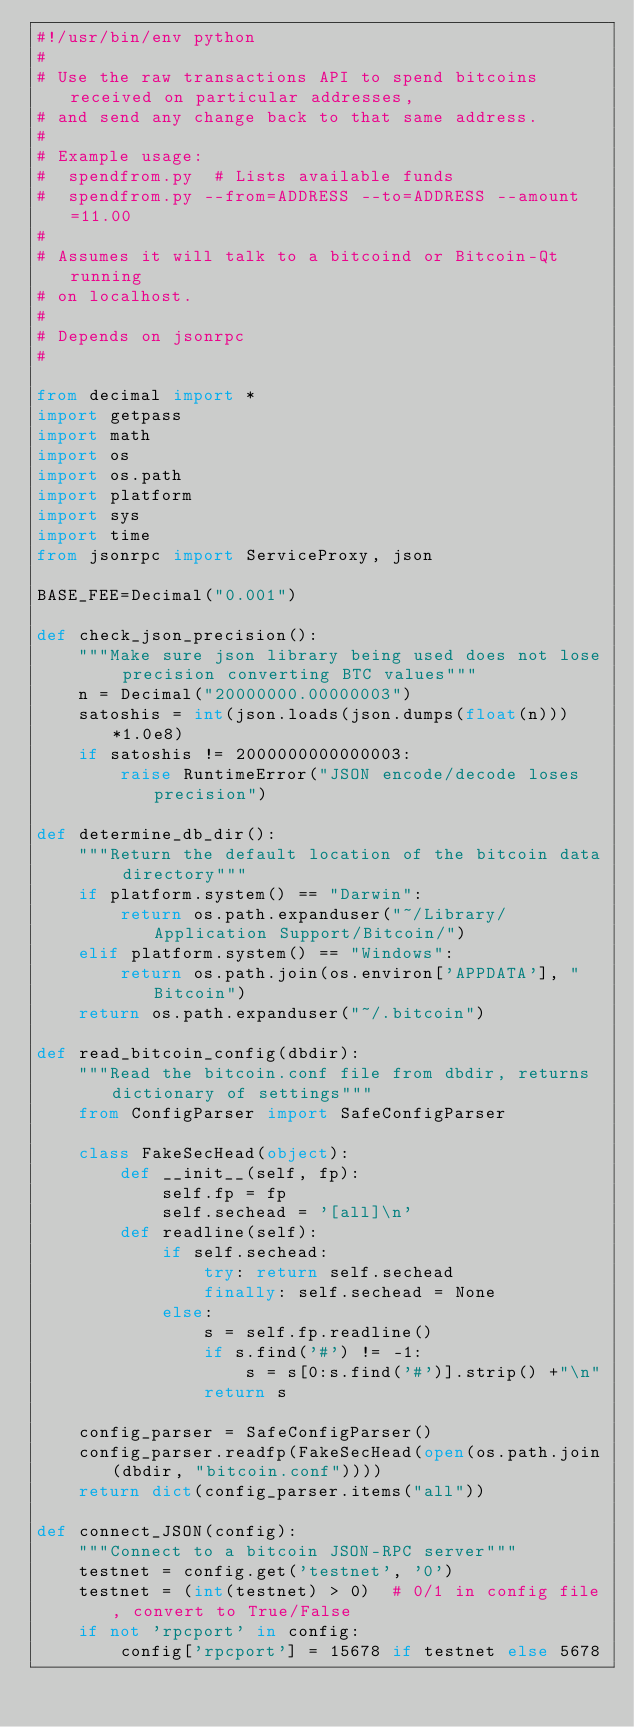<code> <loc_0><loc_0><loc_500><loc_500><_Python_>#!/usr/bin/env python
#
# Use the raw transactions API to spend bitcoins received on particular addresses,
# and send any change back to that same address.
#
# Example usage:
#  spendfrom.py  # Lists available funds
#  spendfrom.py --from=ADDRESS --to=ADDRESS --amount=11.00
#
# Assumes it will talk to a bitcoind or Bitcoin-Qt running
# on localhost.
#
# Depends on jsonrpc
#

from decimal import *
import getpass
import math
import os
import os.path
import platform
import sys
import time
from jsonrpc import ServiceProxy, json

BASE_FEE=Decimal("0.001")

def check_json_precision():
    """Make sure json library being used does not lose precision converting BTC values"""
    n = Decimal("20000000.00000003")
    satoshis = int(json.loads(json.dumps(float(n)))*1.0e8)
    if satoshis != 2000000000000003:
        raise RuntimeError("JSON encode/decode loses precision")

def determine_db_dir():
    """Return the default location of the bitcoin data directory"""
    if platform.system() == "Darwin":
        return os.path.expanduser("~/Library/Application Support/Bitcoin/")
    elif platform.system() == "Windows":
        return os.path.join(os.environ['APPDATA'], "Bitcoin")
    return os.path.expanduser("~/.bitcoin")

def read_bitcoin_config(dbdir):
    """Read the bitcoin.conf file from dbdir, returns dictionary of settings"""
    from ConfigParser import SafeConfigParser

    class FakeSecHead(object):
        def __init__(self, fp):
            self.fp = fp
            self.sechead = '[all]\n'
        def readline(self):
            if self.sechead:
                try: return self.sechead
                finally: self.sechead = None
            else:
                s = self.fp.readline()
                if s.find('#') != -1:
                    s = s[0:s.find('#')].strip() +"\n"
                return s

    config_parser = SafeConfigParser()
    config_parser.readfp(FakeSecHead(open(os.path.join(dbdir, "bitcoin.conf"))))
    return dict(config_parser.items("all"))

def connect_JSON(config):
    """Connect to a bitcoin JSON-RPC server"""
    testnet = config.get('testnet', '0')
    testnet = (int(testnet) > 0)  # 0/1 in config file, convert to True/False
    if not 'rpcport' in config:
        config['rpcport'] = 15678 if testnet else 5678</code> 